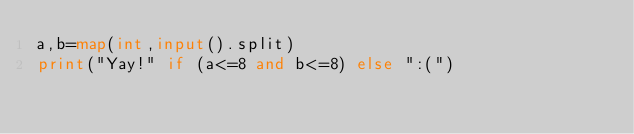Convert code to text. <code><loc_0><loc_0><loc_500><loc_500><_Python_>a,b=map(int,input().split)
print("Yay!" if (a<=8 and b<=8) else ":(")</code> 